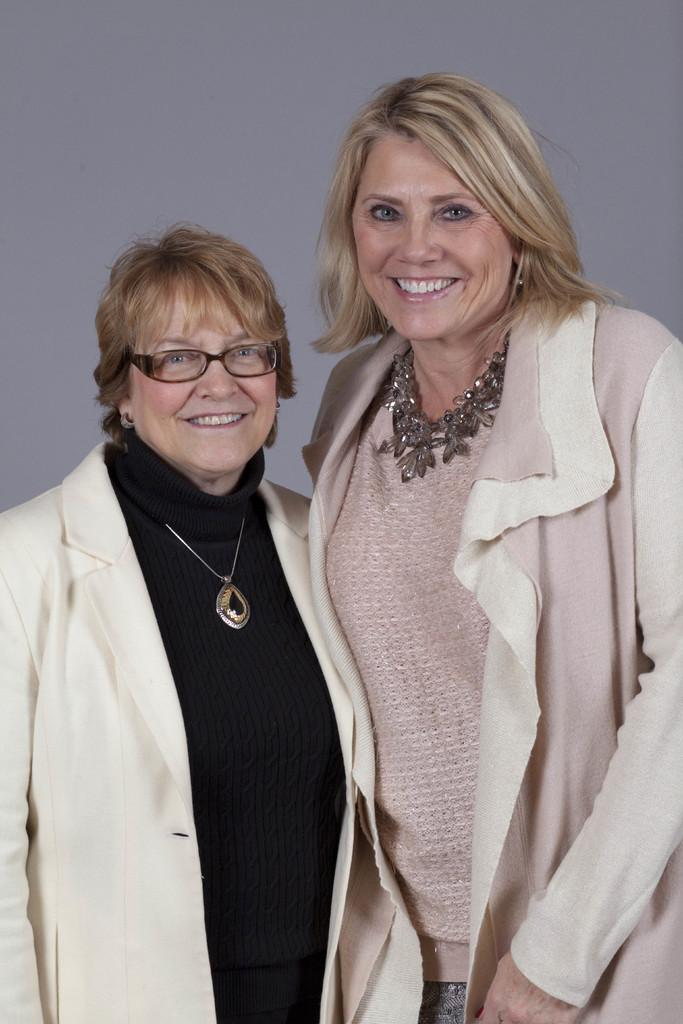How many people are in the image? There are two ladies in the image. What are the ladies wearing? Both ladies are wearing coats and chains. Can you describe any accessories the ladies are wearing? One of the ladies is wearing glasses. What can be seen in the background of the image? There is a wall in the background of the image. What type of silk fabric is draped over the circle in the image? There is no silk fabric or circle present in the image. 